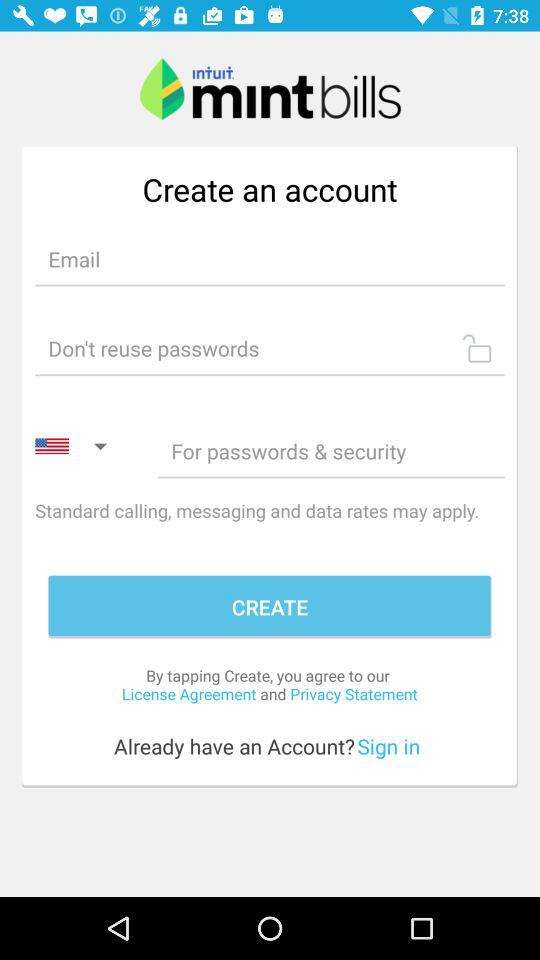What is the application name? The application name is "mint bills". 